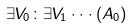Convert formula to latex. <formula><loc_0><loc_0><loc_500><loc_500>\exists V _ { 0 } \colon \exists V _ { 1 } \cdot \cdot \cdot ( A _ { 0 } )</formula> 